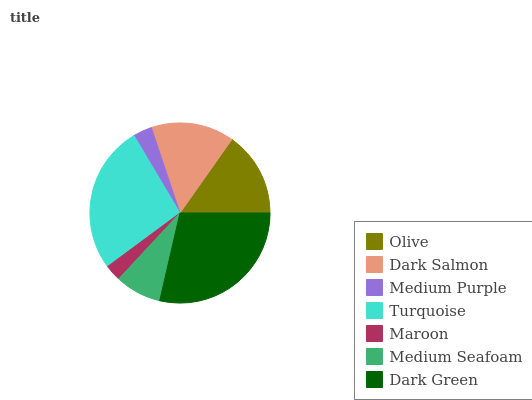Is Maroon the minimum?
Answer yes or no. Yes. Is Dark Green the maximum?
Answer yes or no. Yes. Is Dark Salmon the minimum?
Answer yes or no. No. Is Dark Salmon the maximum?
Answer yes or no. No. Is Olive greater than Dark Salmon?
Answer yes or no. Yes. Is Dark Salmon less than Olive?
Answer yes or no. Yes. Is Dark Salmon greater than Olive?
Answer yes or no. No. Is Olive less than Dark Salmon?
Answer yes or no. No. Is Dark Salmon the high median?
Answer yes or no. Yes. Is Dark Salmon the low median?
Answer yes or no. Yes. Is Medium Purple the high median?
Answer yes or no. No. Is Medium Seafoam the low median?
Answer yes or no. No. 